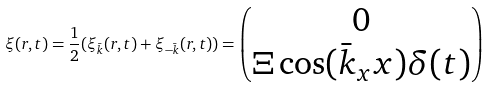<formula> <loc_0><loc_0><loc_500><loc_500>\xi ( r , t ) = \frac { 1 } { 2 } ( \xi _ { \bar { k } } ( r , t ) + \xi _ { - \bar { k } } ( r , t ) ) = \begin{pmatrix} 0 \\ \Xi \cos ( \bar { k } _ { x } x ) \delta ( t ) \end{pmatrix}</formula> 